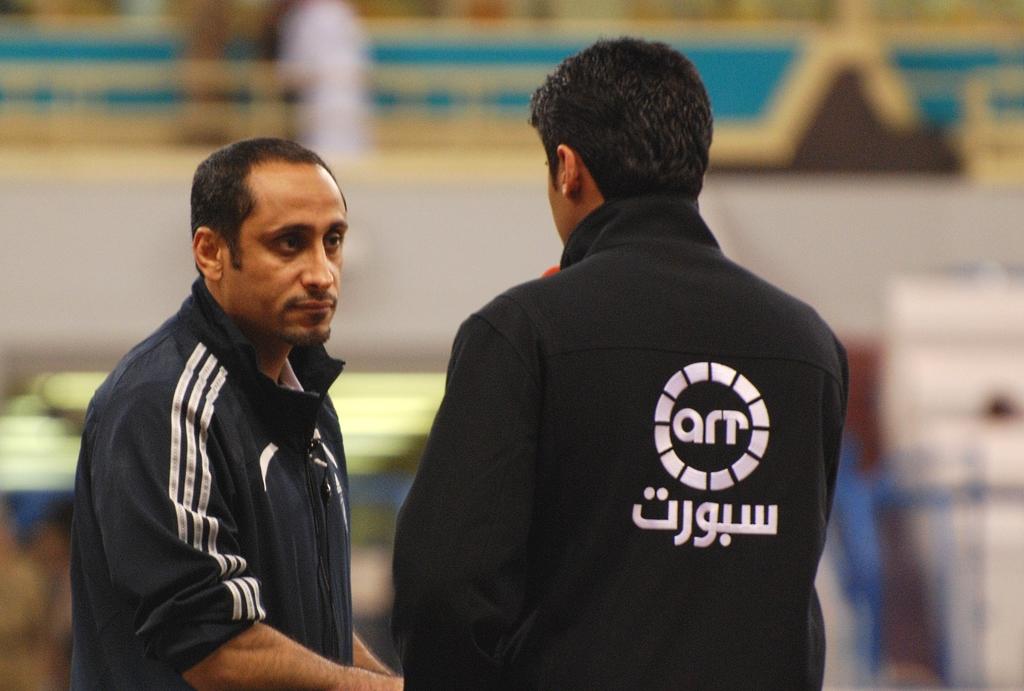What sponsor or brand is on the man's jacket?
Give a very brief answer. Arr. 